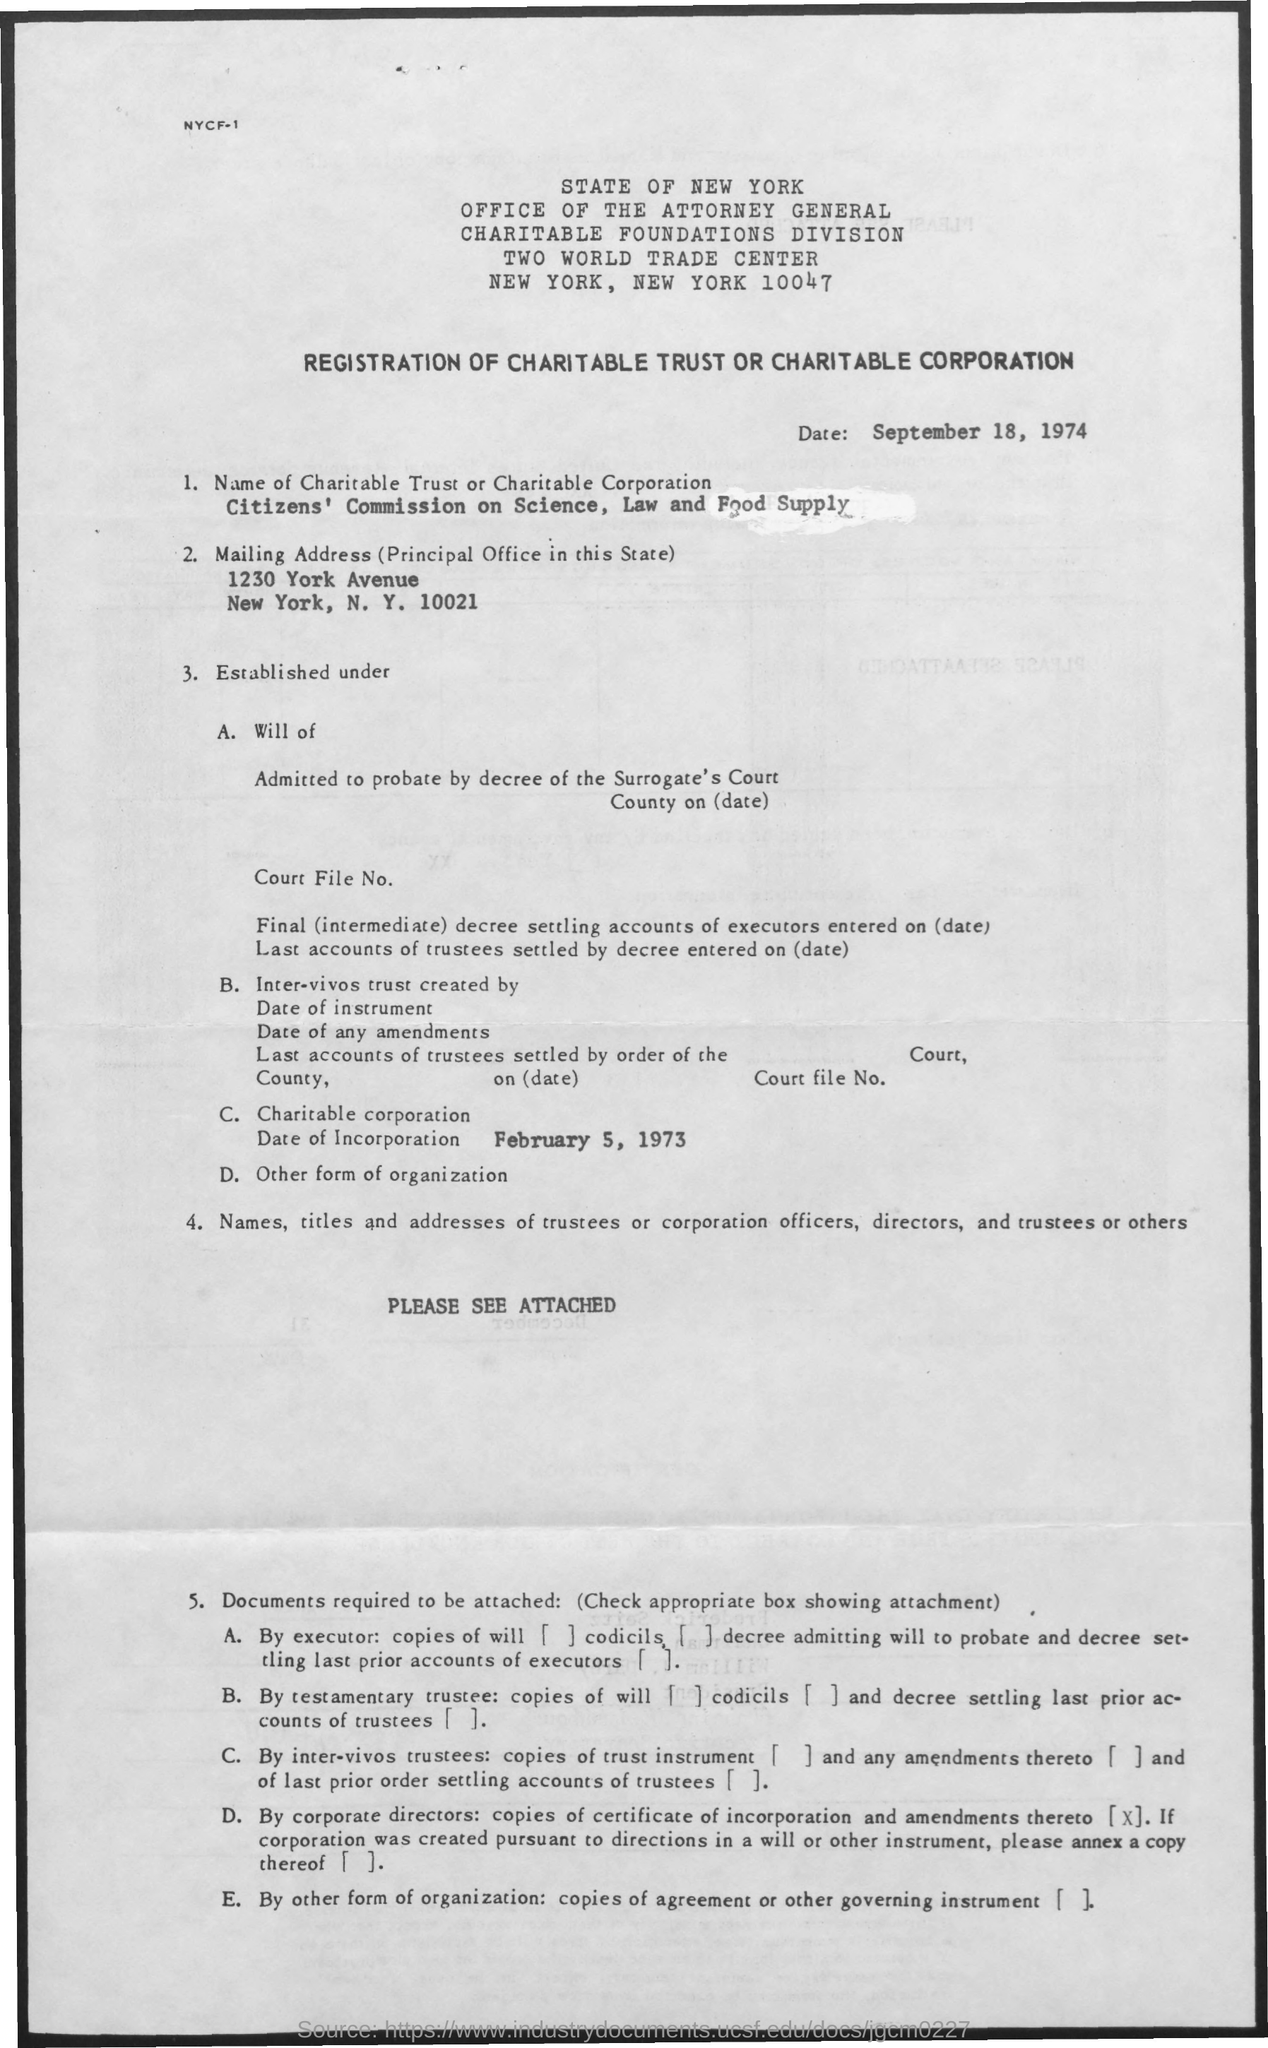Identify some key points in this picture. On February 5, 1973, the charitable corporation was incorporated. 